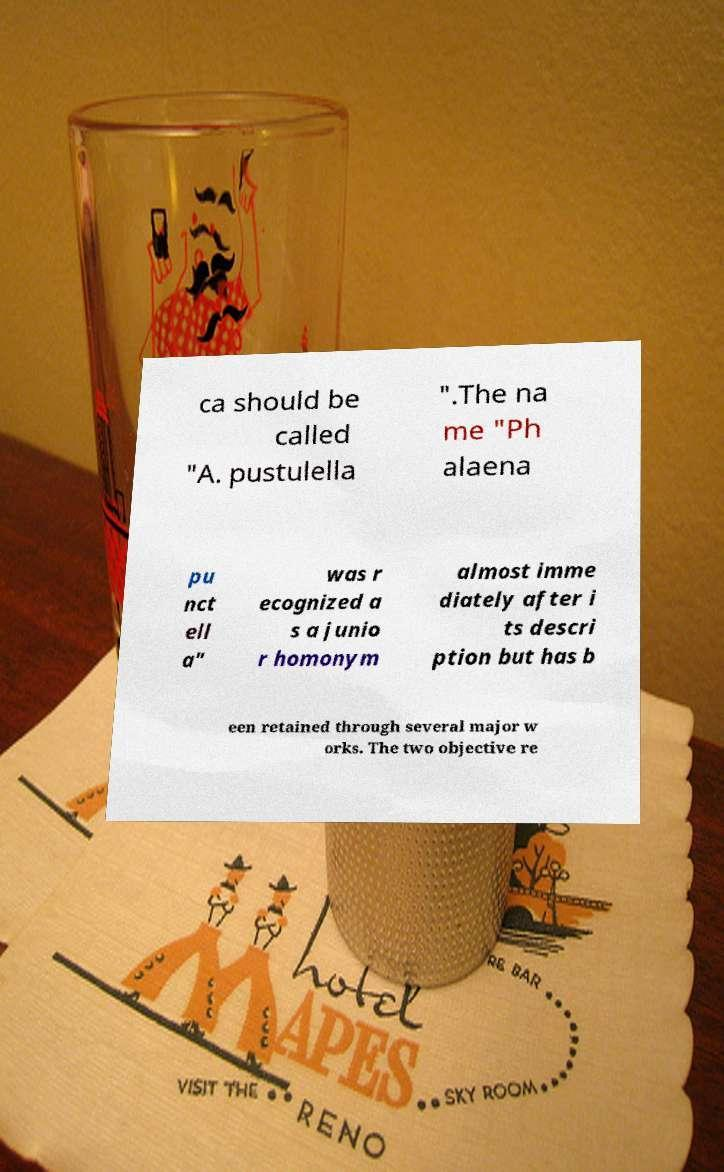For documentation purposes, I need the text within this image transcribed. Could you provide that? ca should be called "A. pustulella ".The na me "Ph alaena pu nct ell a" was r ecognized a s a junio r homonym almost imme diately after i ts descri ption but has b een retained through several major w orks. The two objective re 